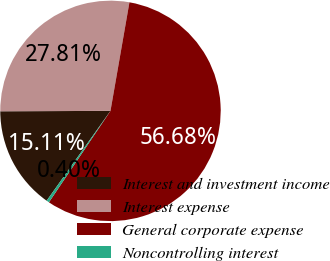Convert chart to OTSL. <chart><loc_0><loc_0><loc_500><loc_500><pie_chart><fcel>Interest and investment income<fcel>Interest expense<fcel>General corporate expense<fcel>Noncontrolling interest<nl><fcel>15.11%<fcel>27.81%<fcel>56.68%<fcel>0.4%<nl></chart> 